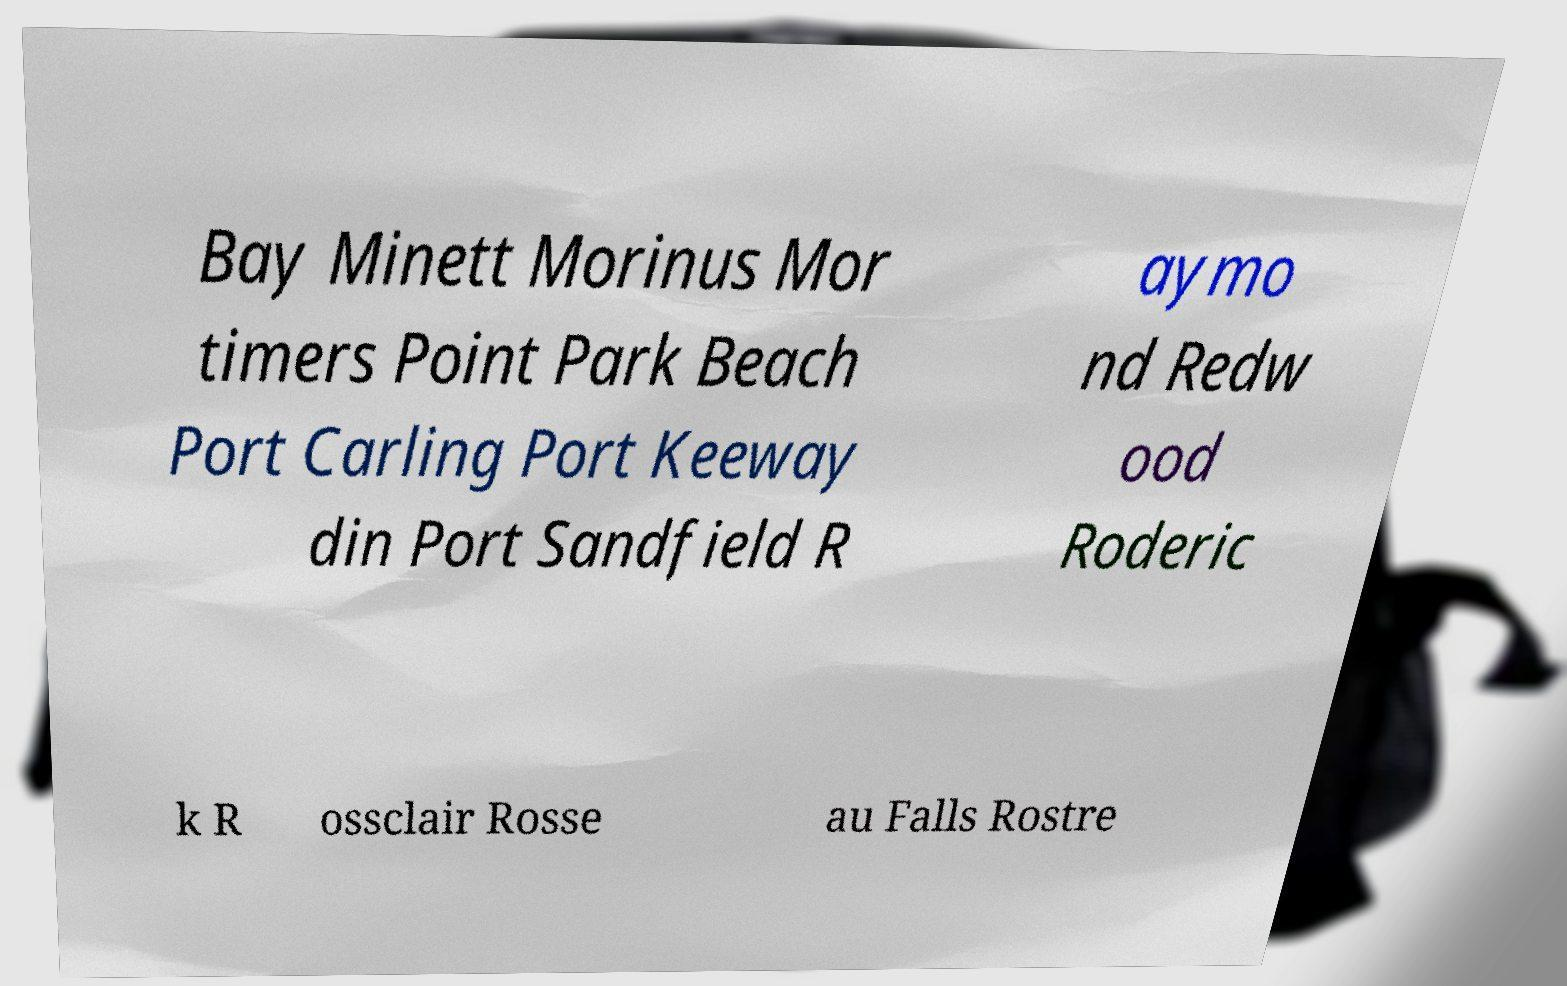For documentation purposes, I need the text within this image transcribed. Could you provide that? Bay Minett Morinus Mor timers Point Park Beach Port Carling Port Keeway din Port Sandfield R aymo nd Redw ood Roderic k R ossclair Rosse au Falls Rostre 